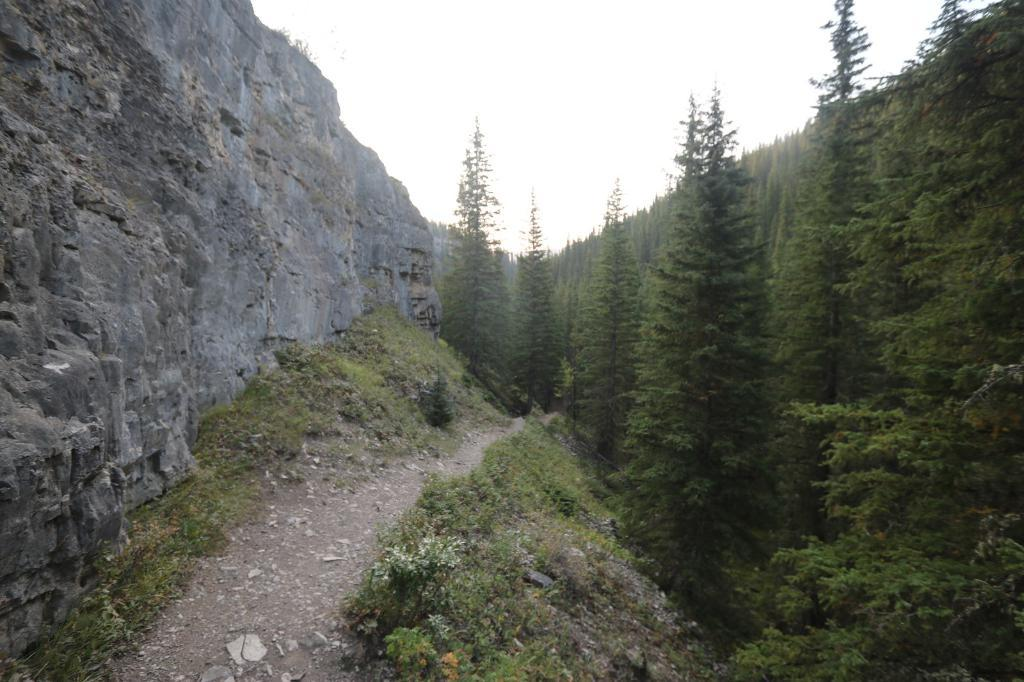What type of natural elements can be seen in the image? There are many trees in the image. What other object can be seen in the image besides the trees? There is a big rock in the image. Can you see any dinosaurs roaming around in the image? No, there are no dinosaurs present in the image. 